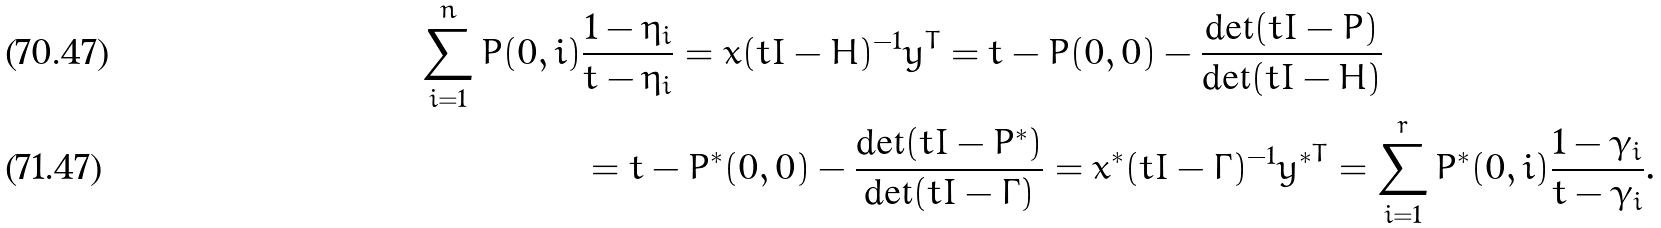Convert formula to latex. <formula><loc_0><loc_0><loc_500><loc_500>\sum _ { i = 1 } ^ { n } P ( 0 , i ) & \frac { 1 - \eta _ { i } } { t - \eta _ { i } } = x ( t I - H ) ^ { - 1 } y ^ { T } = t - P ( 0 , 0 ) - \frac { \det ( t I - P ) } { \det ( t I - H ) } \\ & = t - P ^ { * } ( 0 , 0 ) - \frac { \det ( t I - P ^ { * } ) } { \det ( t I - \Gamma ) } = x ^ { * } ( t I - \Gamma ) ^ { - 1 } { y ^ { * } } ^ { T } = \sum _ { i = 1 } ^ { r } P ^ { * } ( 0 , i ) \frac { 1 - \gamma _ { i } } { t - \gamma _ { i } } .</formula> 